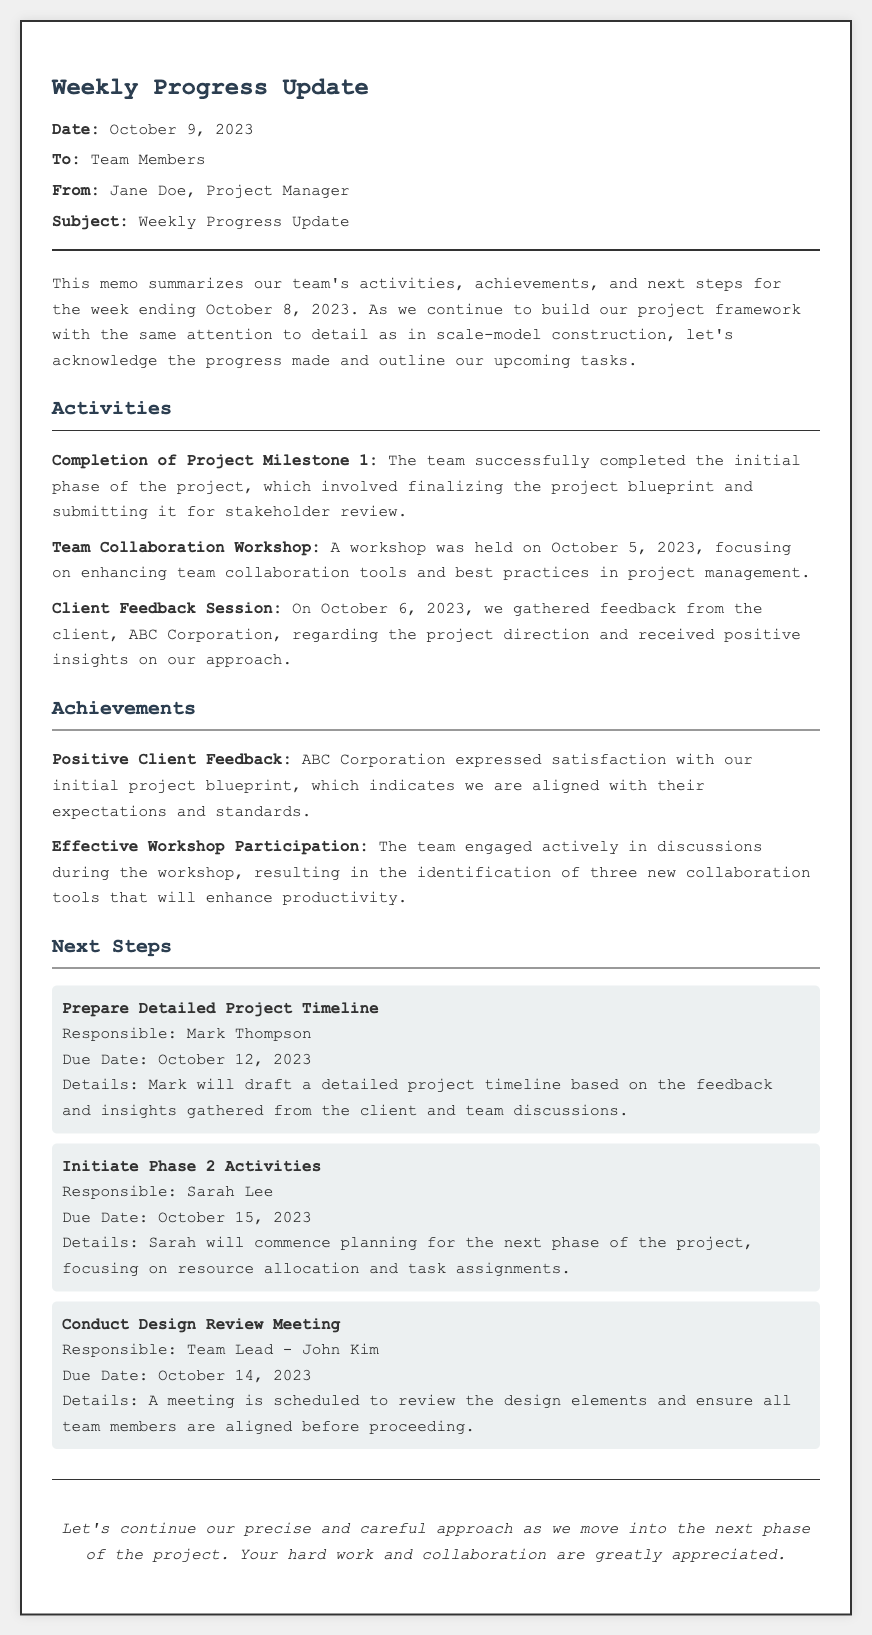what is the date of the memo? The date of the memo is mentioned in the header section.
Answer: October 9, 2023 who is the sender of the memo? The sender is identified in the header section of the document.
Answer: Jane Doe what was the main focus of the Team Collaboration Workshop? The focus is described in the Activities section.
Answer: Enhancing team collaboration tools and best practices in project management who is responsible for preparing the detailed project timeline? Responsibility for this task is assigned in the Next Steps section.
Answer: Mark Thompson what is the due date for initiating Phase 2 activities? The due date is provided in the Next Steps section under that specific task.
Answer: October 15, 2023 how many new collaboration tools were identified during the workshop? This answer can be derived from the Achievements section regarding the workshop participation.
Answer: Three what is the subject of the memo? The subject is stated in the header section of the memo.
Answer: Weekly Progress Update what feedback did the team receive from the client? The feedback is summarized in the Achievements section.
Answer: Satisfaction with the initial project blueprint what is the next scheduled meeting and who is responsible for it? This can be found in the Next Steps section addressing the specific task.
Answer: Conduct Design Review Meeting, Team Lead - John Kim 